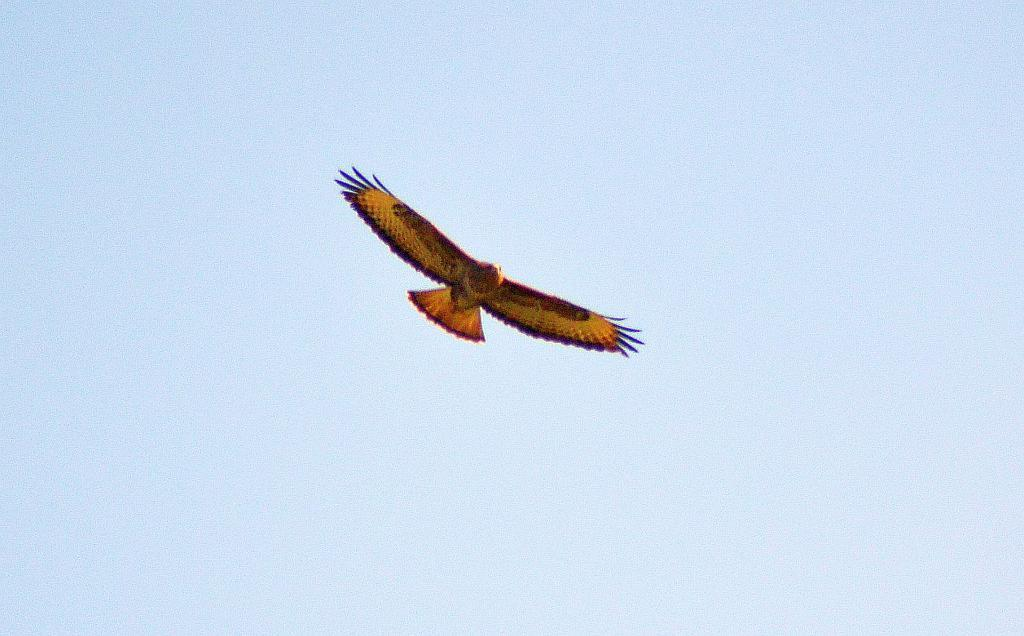What is the main subject of the image? The main subject of the image is a bird flying. What colors can be seen on the bird? The bird is in yellow and red colors. What can be seen in the background of the image? There is a sky visible in the background of the image, and clouds are present. What type of building can be seen in the background of the image? There is no building present in the background of the image; it only features the sky and clouds. Can you tell me how many brains are visible in the image? There are no brains visible in the image; it only features a bird flying and the sky with clouds. 